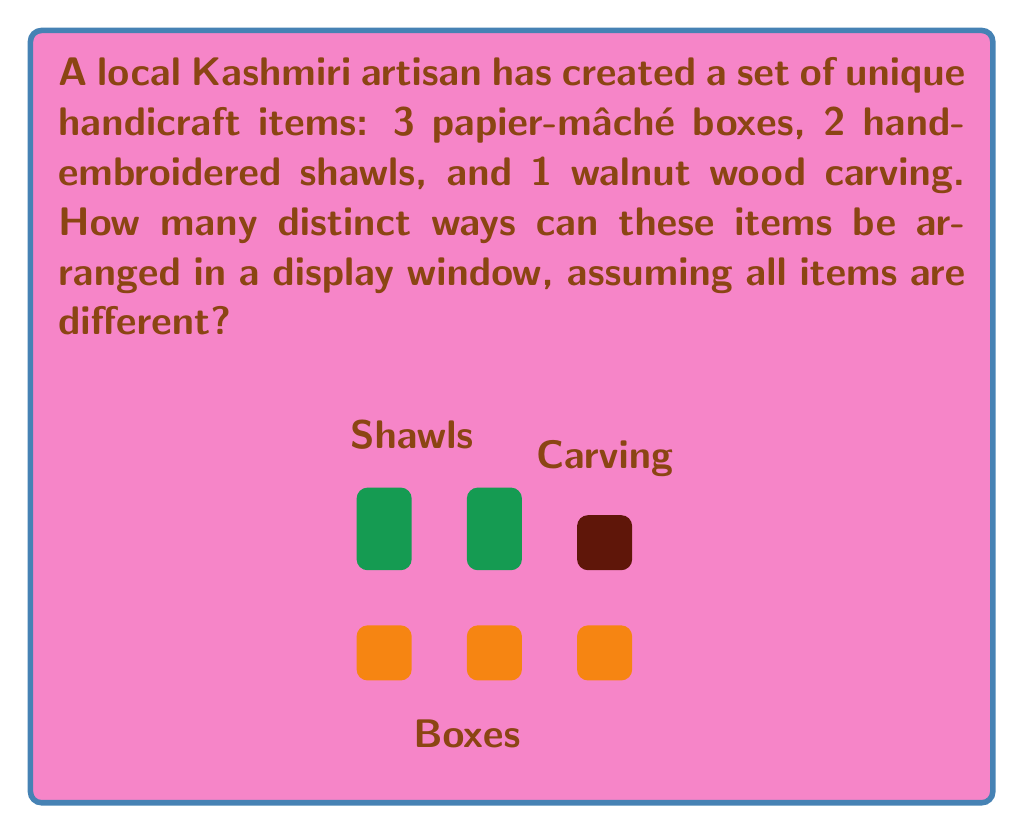Provide a solution to this math problem. To solve this problem, we need to use the fundamental principle of counting in permutations. Since all items are considered different, we can treat this as a straightforward permutation problem.

Let's approach this step-by-step:

1) First, we need to count the total number of items:
   3 papier-mâché boxes + 2 hand-embroidered shawls + 1 walnut wood carving = 6 items in total

2) Now, we need to calculate the number of ways to arrange 6 distinct items. This is given by the factorial of 6, denoted as 6!

3) The formula for this permutation is:

   $$P(6) = 6!$$

4) Let's calculate 6!:
   $$6! = 6 \times 5 \times 4 \times 3 \times 2 \times 1 = 720$$

Therefore, there are 720 distinct ways to arrange these 6 unique Kashmiri handicraft items in the display window.

This calculation ensures that each arrangement is unique, showcasing the diversity of Kashmiri craftsmanship in every possible way, which could be appealing to both locals and tourists interested in the region's rich artistic heritage.
Answer: 720 